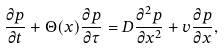<formula> <loc_0><loc_0><loc_500><loc_500>\frac { \partial p } { \partial t } + \Theta ( x ) \frac { \partial p } { \partial \tau } = D \frac { \partial ^ { 2 } p } { \partial x ^ { 2 } } + v \frac { \partial p } { \partial x } ,</formula> 